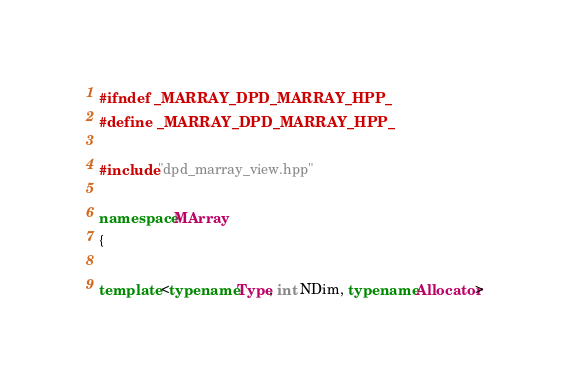Convert code to text. <code><loc_0><loc_0><loc_500><loc_500><_C++_>#ifndef _MARRAY_DPD_MARRAY_HPP_
#define _MARRAY_DPD_MARRAY_HPP_

#include "dpd_marray_view.hpp"

namespace MArray
{

template <typename Type, int NDim, typename Allocator></code> 